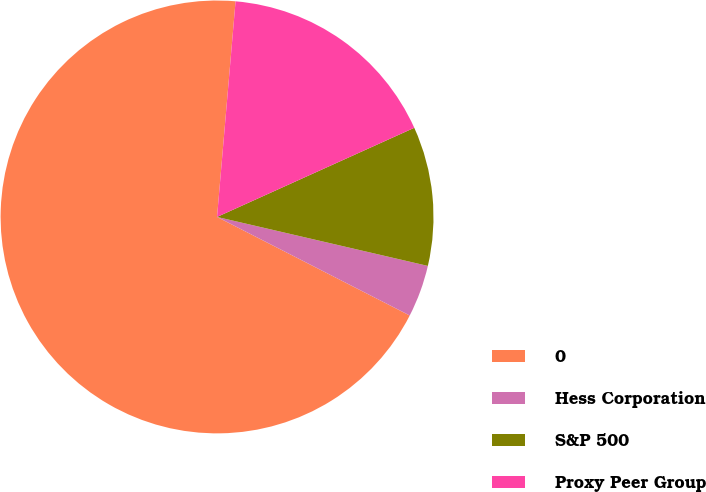<chart> <loc_0><loc_0><loc_500><loc_500><pie_chart><fcel>0<fcel>Hess Corporation<fcel>S&P 500<fcel>Proxy Peer Group<nl><fcel>68.84%<fcel>3.89%<fcel>10.39%<fcel>16.88%<nl></chart> 